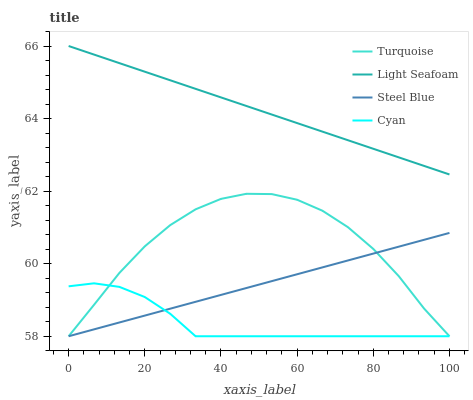Does Cyan have the minimum area under the curve?
Answer yes or no. Yes. Does Light Seafoam have the maximum area under the curve?
Answer yes or no. Yes. Does Turquoise have the minimum area under the curve?
Answer yes or no. No. Does Turquoise have the maximum area under the curve?
Answer yes or no. No. Is Steel Blue the smoothest?
Answer yes or no. Yes. Is Turquoise the roughest?
Answer yes or no. Yes. Is Light Seafoam the smoothest?
Answer yes or no. No. Is Light Seafoam the roughest?
Answer yes or no. No. Does Light Seafoam have the lowest value?
Answer yes or no. No. Does Light Seafoam have the highest value?
Answer yes or no. Yes. Does Turquoise have the highest value?
Answer yes or no. No. Is Turquoise less than Light Seafoam?
Answer yes or no. Yes. Is Light Seafoam greater than Turquoise?
Answer yes or no. Yes. Does Steel Blue intersect Turquoise?
Answer yes or no. Yes. Is Steel Blue less than Turquoise?
Answer yes or no. No. Is Steel Blue greater than Turquoise?
Answer yes or no. No. Does Turquoise intersect Light Seafoam?
Answer yes or no. No. 